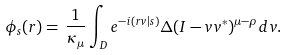<formula> <loc_0><loc_0><loc_500><loc_500>\phi _ { s } ( r ) = \, \frac { 1 } { \kappa _ { \mu } } \int _ { D } e ^ { - i ( r v | s ) } \Delta ( I - v v ^ { * } ) ^ { \mu - \rho } d v .</formula> 